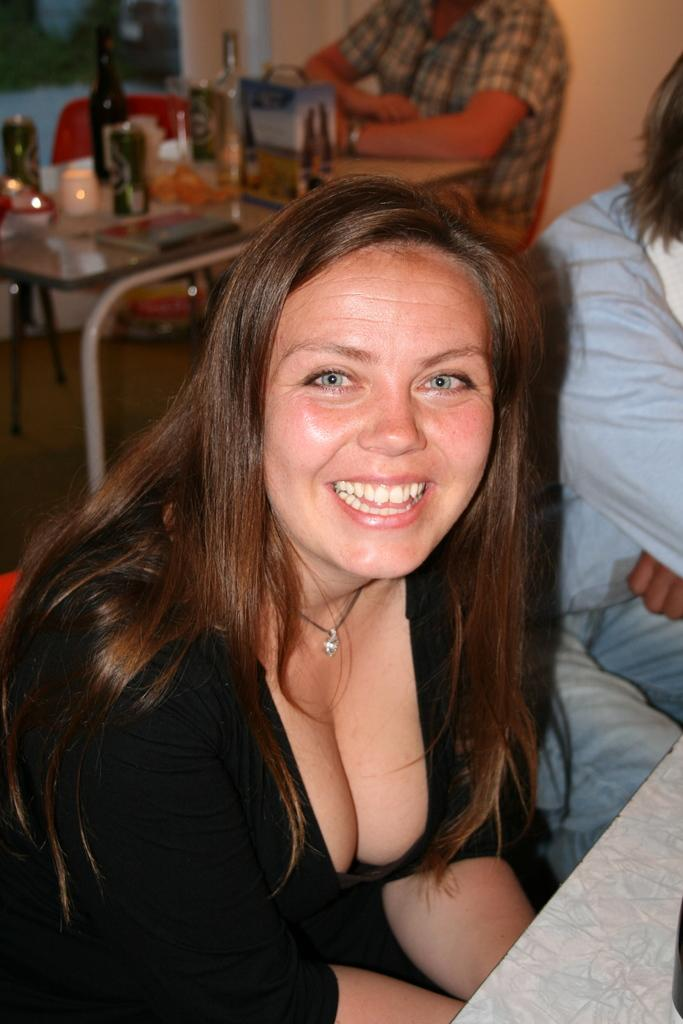Who is the main subject in the image? There is a woman in the image. What is the woman doing in the image? The woman is sitting on a chair and smiling. Can you describe the person in the background of the image? The person in the background is sitting on a chair as well. What type of light is being used to illuminate the prison in the image? There is no prison present in the image, and therefore no light source can be identified for it. 